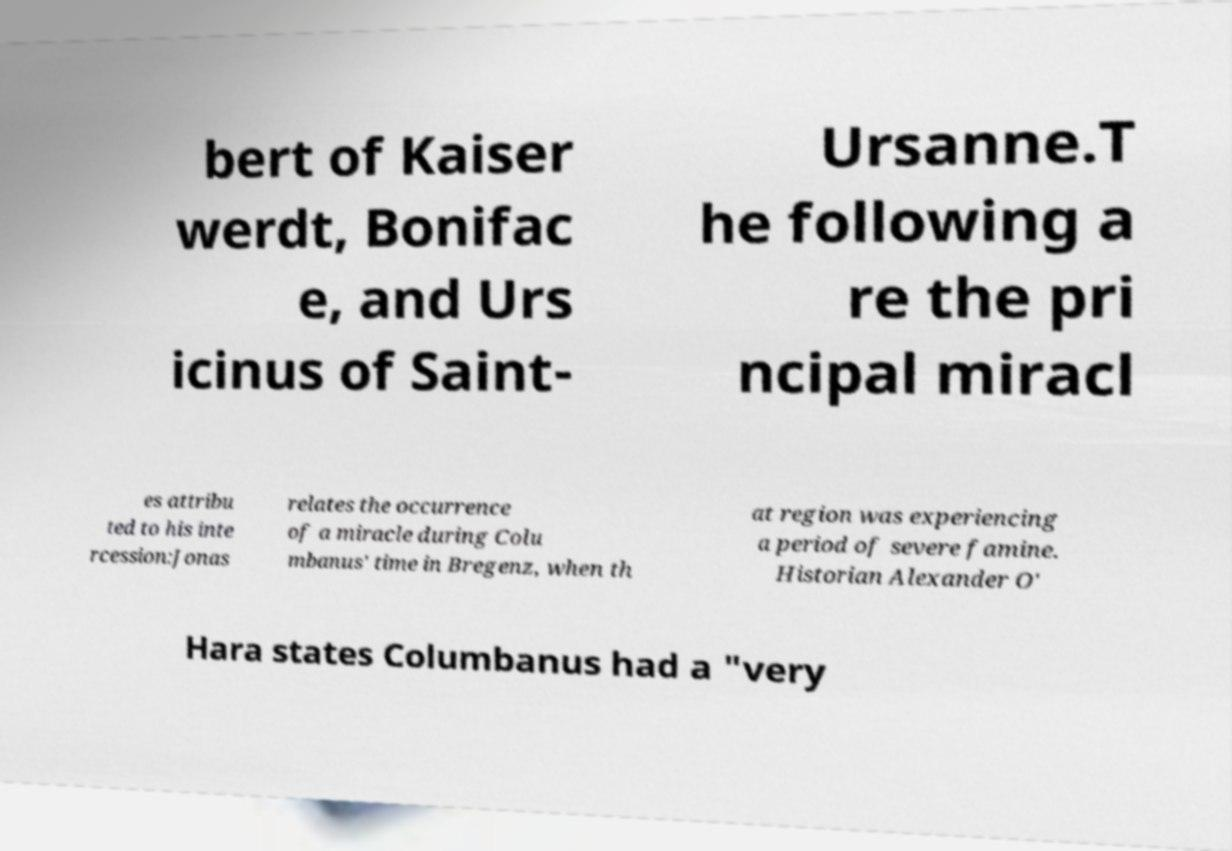Could you assist in decoding the text presented in this image and type it out clearly? bert of Kaiser werdt, Bonifac e, and Urs icinus of Saint- Ursanne.T he following a re the pri ncipal miracl es attribu ted to his inte rcession:Jonas relates the occurrence of a miracle during Colu mbanus' time in Bregenz, when th at region was experiencing a period of severe famine. Historian Alexander O' Hara states Columbanus had a "very 